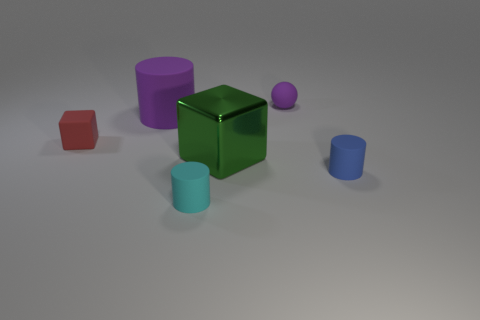What colors are present in the image, and do any objects share the same color? The image displays a variety of colors including red, green, purple, teal, and two different shades of blue. None of the objects share an identical color; each has a distinct hue.  Could you describe the overall mood or theme suggested by this collection of objects? The assortment of geometric shapes and the muted, pastel color palette evoke a calm and orderly mood, possibly conveying themes of harmony and simplicity. 